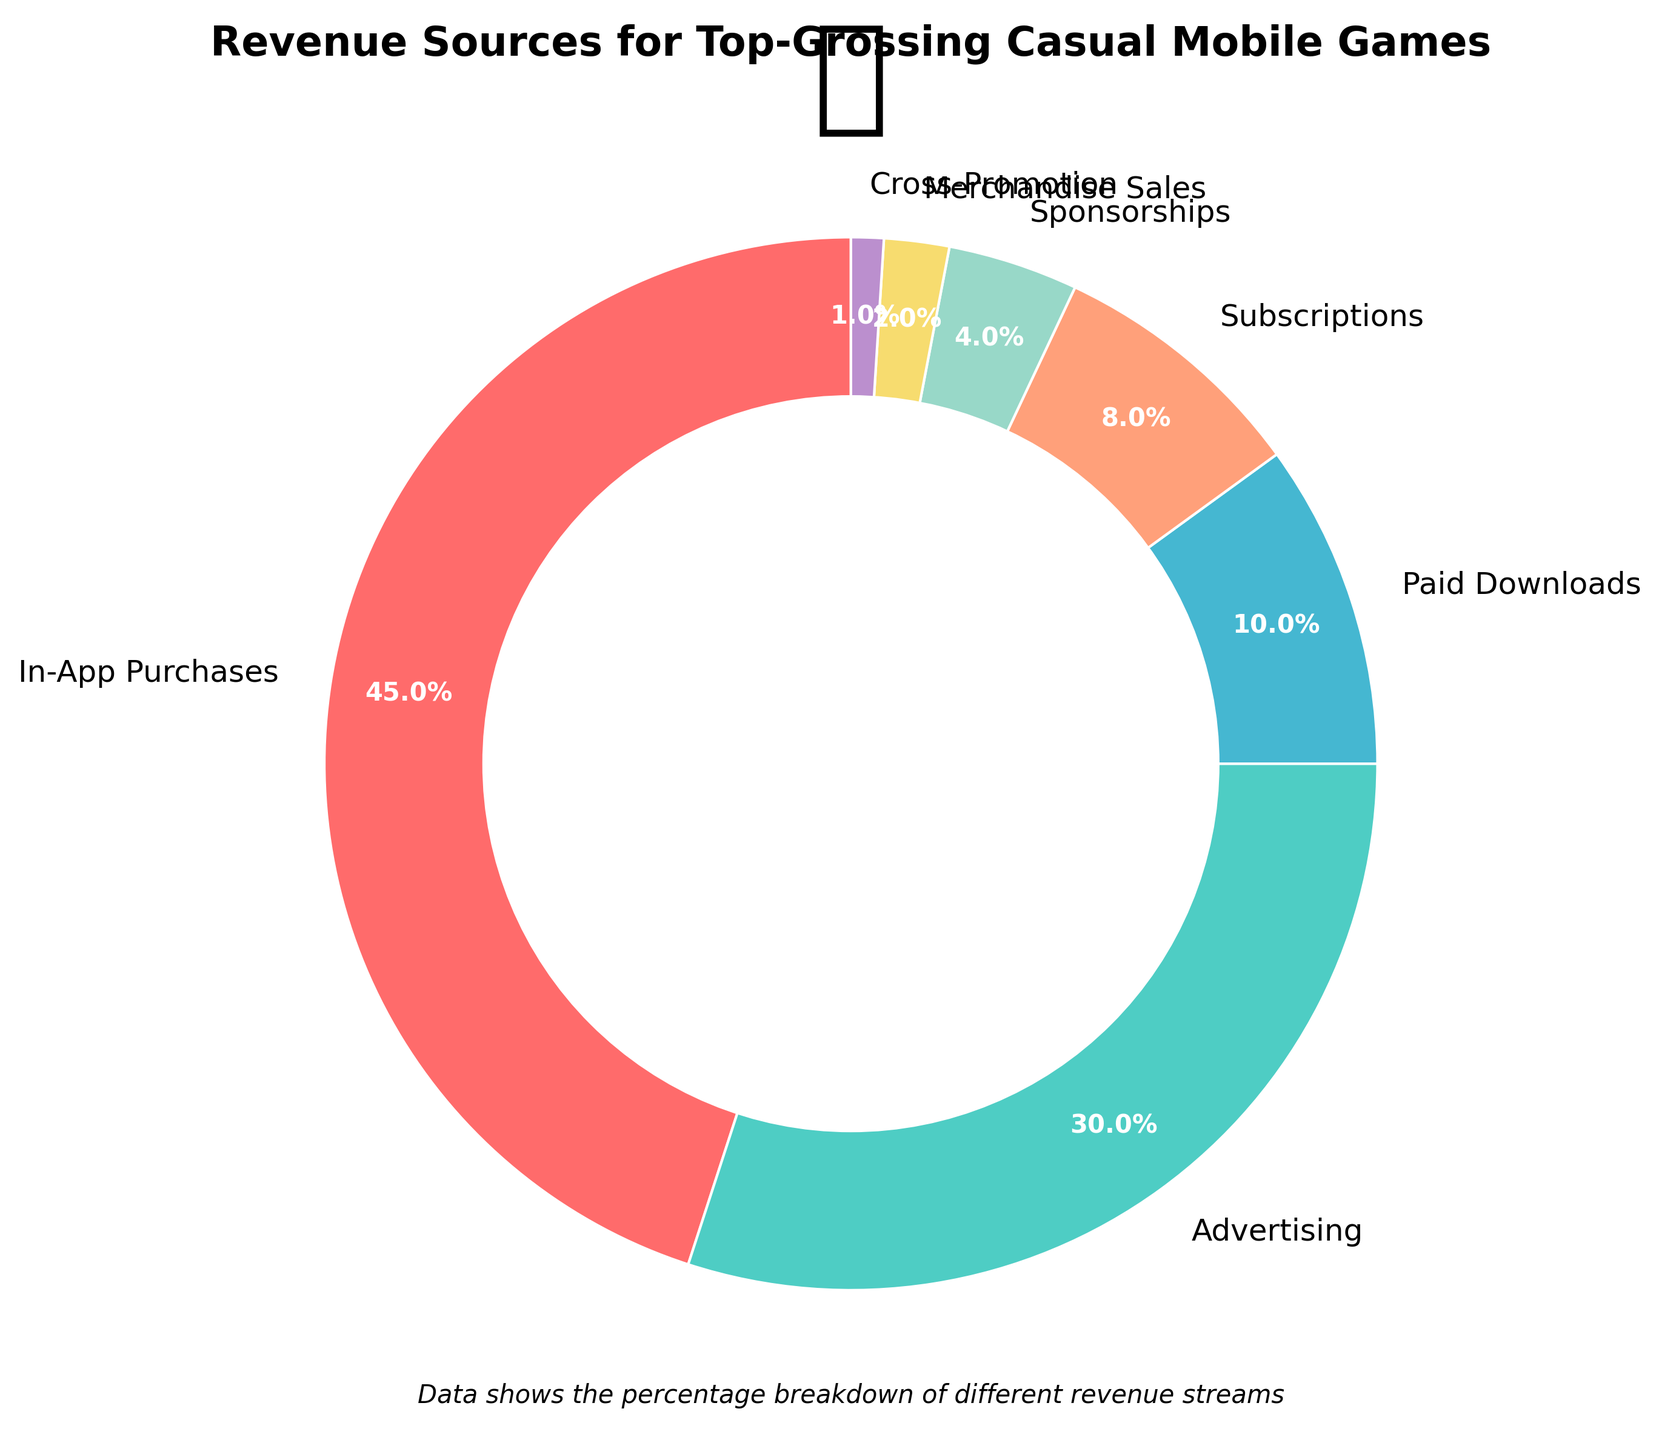What's the largest source of revenue for top-grossing casual mobile games? By looking at the size of the segments in the pie chart, the largest segment represents In-App Purchases, which is 45%.
Answer: In-App Purchases How much larger is the percentage of revenue from Advertising than from Paid Downloads? Advertising constitutes 30% of the revenue, while Paid Downloads make up 10%. The difference between them is 30% - 10% = 20%.
Answer: 20% Which source of revenue holds the smallest percentage, and what is that percentage? The smallest segment in the pie chart is Cross-Promotion, which represents 1% of the total revenue.
Answer: Cross-Promotion, 1% What is the combined percentage of revenue from Subscriptions and Sponsorships? Subscriptions account for 8%, and Sponsorships account for 4%. Their combined percentage is 8% + 4% = 12%.
Answer: 12% Compare the revenue from In-App Purchases to the combined revenue from Advertising and Paid Downloads. Which is larger and by how much? In-App Purchases account for 45%, while the combined revenue from Advertising and Paid Downloads is 30% + 10% = 40%. In-App Purchases are larger by 45% - 40% = 5%.
Answer: In-App Purchases, 5% What percentage of the revenue comes from non-purchase sources (Advertising, Sponsorships, and Merchandise Sales combined)? Advertising is 30%, Sponsorships are 4%, and Merchandise Sales are 2%. The combined percentage is 30% + 4% + 2% = 36%.
Answer: 36% What is the sum of revenue percentages from all sources except Advertising? The total percentage from all sources is 100%. Subtracting the 30% from Advertising gives us 100% - 30% = 70%.
Answer: 70% Describe the color of the segment that represents Subscriptions. The pie chart shows that the segment representing Subscriptions is filled with a light orange color.
Answer: Light orange How many revenue sources contribute less than 10% each? By examining the chart, the following sources contribute less than 10% each: Paid Downloads (10%), Subscriptions (8%), Sponsorships (4%), Merchandise Sales (2%), and Cross-Promotion (1%). This makes 5 sources in total.
Answer: 5 What do the majority of revenue sources (detailed by percentage) add up to? The majority of revenue, which can be considered more than 50%, comes from In-App Purchases (45%) and Advertising (30%). Together, these add up to 45% + 30% = 75%.
Answer: 75% 